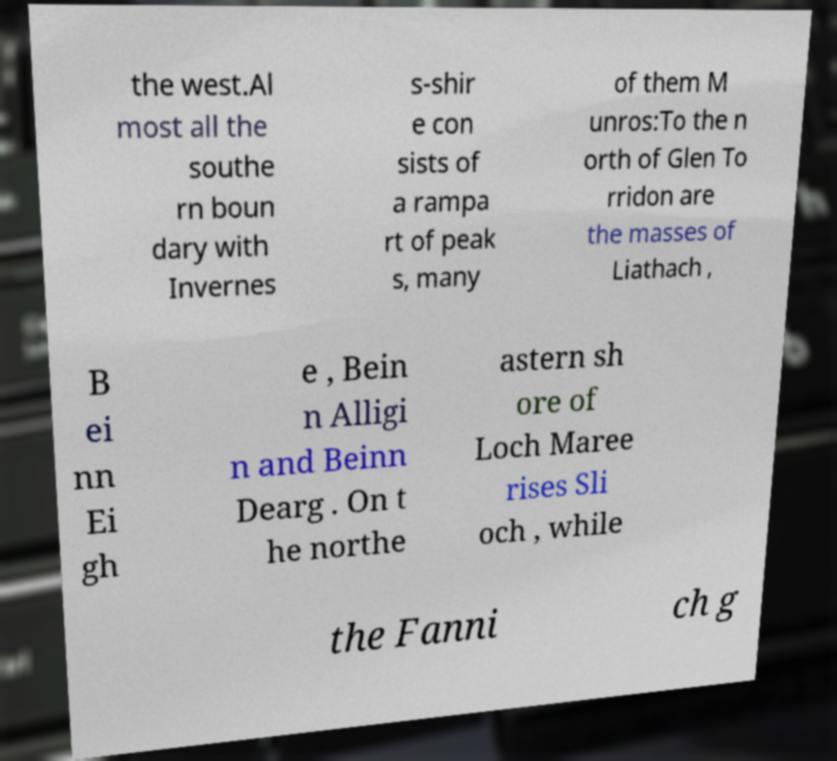Please identify and transcribe the text found in this image. the west.Al most all the southe rn boun dary with Invernes s-shir e con sists of a rampa rt of peak s, many of them M unros:To the n orth of Glen To rridon are the masses of Liathach , B ei nn Ei gh e , Bein n Alligi n and Beinn Dearg . On t he northe astern sh ore of Loch Maree rises Sli och , while the Fanni ch g 